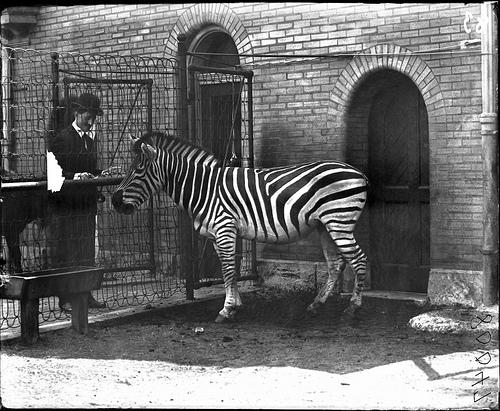Is the picture in black and white?
Be succinct. Yes. Is the picture colored?
Quick response, please. No. What animal is this?
Give a very brief answer. Zebra. 